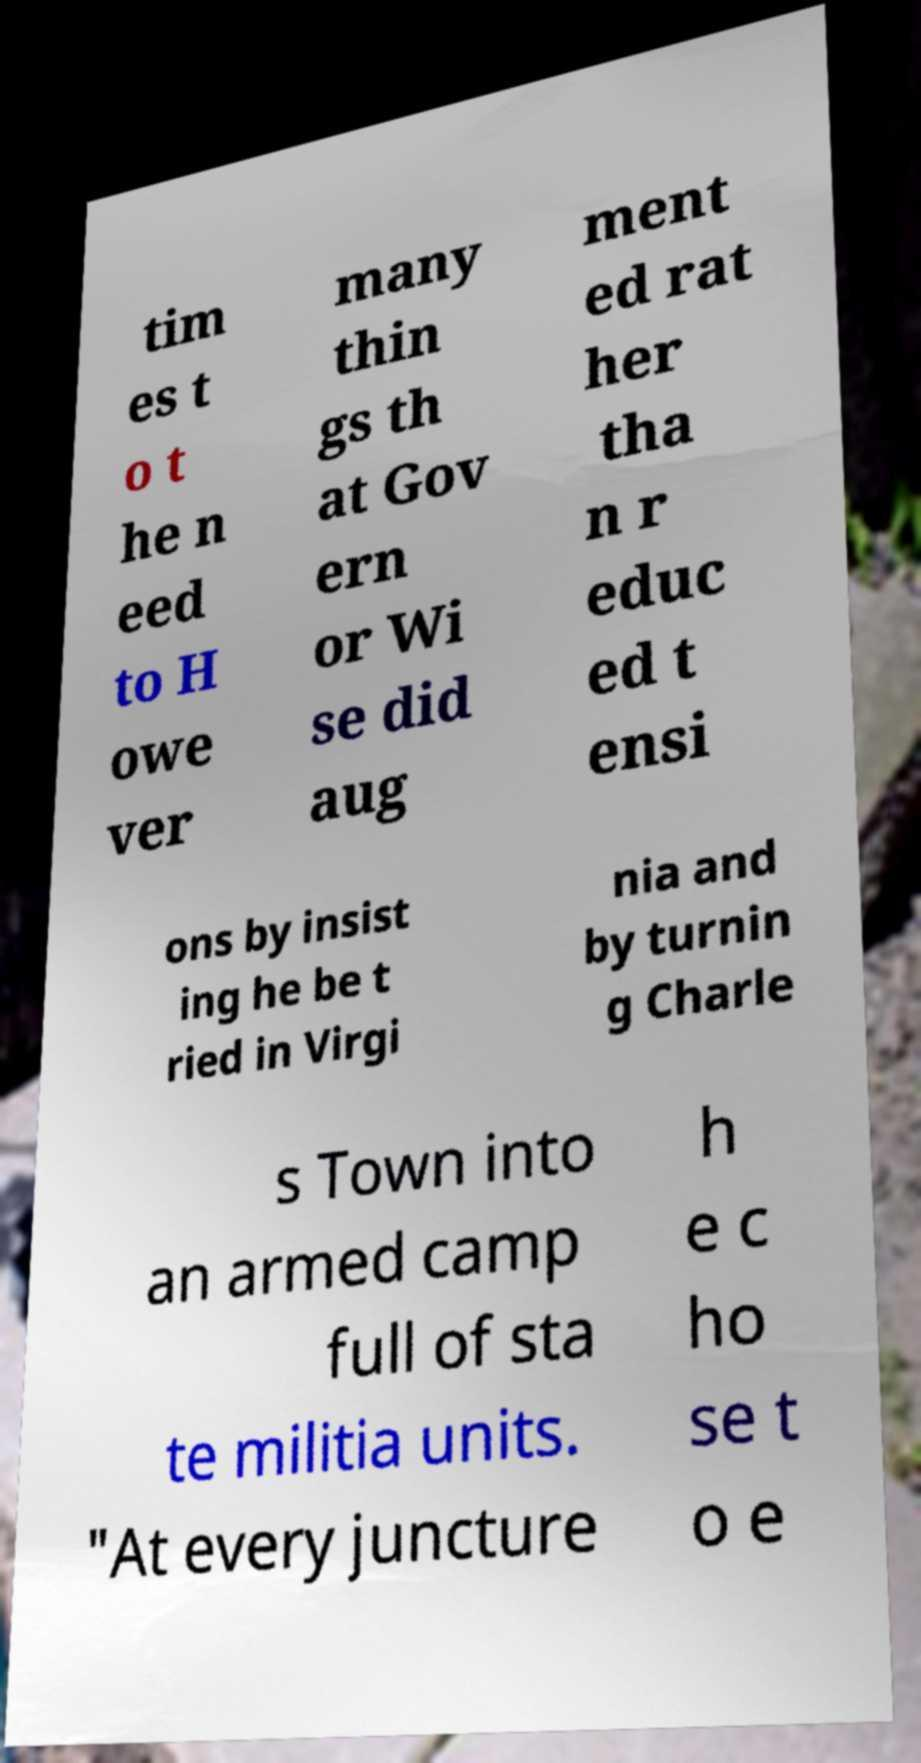Please read and relay the text visible in this image. What does it say? tim es t o t he n eed to H owe ver many thin gs th at Gov ern or Wi se did aug ment ed rat her tha n r educ ed t ensi ons by insist ing he be t ried in Virgi nia and by turnin g Charle s Town into an armed camp full of sta te militia units. "At every juncture h e c ho se t o e 